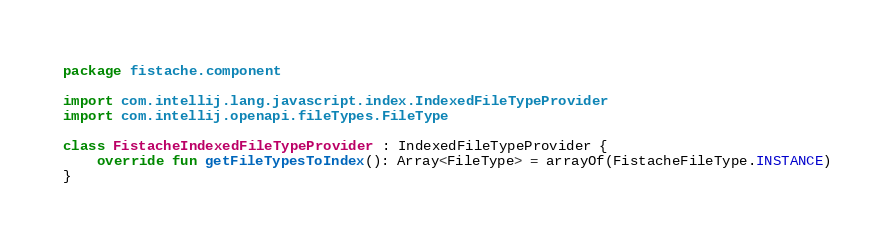<code> <loc_0><loc_0><loc_500><loc_500><_Kotlin_>package fistache.component

import com.intellij.lang.javascript.index.IndexedFileTypeProvider
import com.intellij.openapi.fileTypes.FileType

class FistacheIndexedFileTypeProvider : IndexedFileTypeProvider {
    override fun getFileTypesToIndex(): Array<FileType> = arrayOf(FistacheFileType.INSTANCE)
}
</code> 